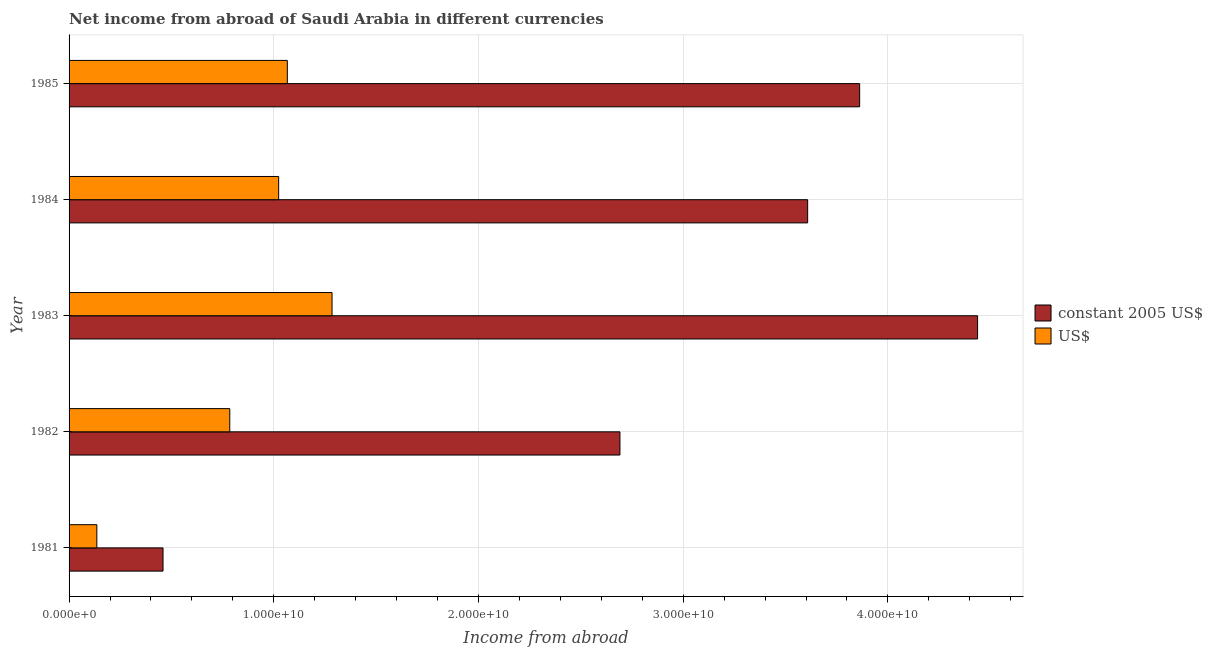How many different coloured bars are there?
Keep it short and to the point. 2. How many groups of bars are there?
Keep it short and to the point. 5. Are the number of bars on each tick of the Y-axis equal?
Your response must be concise. Yes. How many bars are there on the 1st tick from the top?
Offer a terse response. 2. What is the income from abroad in constant 2005 us$ in 1982?
Keep it short and to the point. 2.69e+1. Across all years, what is the maximum income from abroad in constant 2005 us$?
Ensure brevity in your answer.  4.44e+1. Across all years, what is the minimum income from abroad in constant 2005 us$?
Make the answer very short. 4.59e+09. In which year was the income from abroad in us$ minimum?
Provide a succinct answer. 1981. What is the total income from abroad in constant 2005 us$ in the graph?
Keep it short and to the point. 1.51e+11. What is the difference between the income from abroad in constant 2005 us$ in 1982 and that in 1985?
Keep it short and to the point. -1.17e+1. What is the difference between the income from abroad in us$ in 1984 and the income from abroad in constant 2005 us$ in 1985?
Your answer should be compact. -2.84e+1. What is the average income from abroad in constant 2005 us$ per year?
Keep it short and to the point. 3.01e+1. In the year 1984, what is the difference between the income from abroad in us$ and income from abroad in constant 2005 us$?
Provide a succinct answer. -2.58e+1. In how many years, is the income from abroad in us$ greater than 2000000000 units?
Your answer should be very brief. 4. What is the ratio of the income from abroad in us$ in 1981 to that in 1984?
Ensure brevity in your answer.  0.13. Is the income from abroad in constant 2005 us$ in 1981 less than that in 1984?
Make the answer very short. Yes. Is the difference between the income from abroad in constant 2005 us$ in 1982 and 1983 greater than the difference between the income from abroad in us$ in 1982 and 1983?
Provide a succinct answer. No. What is the difference between the highest and the second highest income from abroad in constant 2005 us$?
Your answer should be very brief. 5.76e+09. What is the difference between the highest and the lowest income from abroad in constant 2005 us$?
Your answer should be compact. 3.98e+1. What does the 2nd bar from the top in 1985 represents?
Ensure brevity in your answer.  Constant 2005 us$. What does the 1st bar from the bottom in 1981 represents?
Provide a succinct answer. Constant 2005 us$. Are all the bars in the graph horizontal?
Your answer should be compact. Yes. How many years are there in the graph?
Keep it short and to the point. 5. What is the difference between two consecutive major ticks on the X-axis?
Provide a succinct answer. 1.00e+1. Does the graph contain grids?
Your response must be concise. Yes. Where does the legend appear in the graph?
Your answer should be compact. Center right. What is the title of the graph?
Offer a terse response. Net income from abroad of Saudi Arabia in different currencies. Does "Fertility rate" appear as one of the legend labels in the graph?
Give a very brief answer. No. What is the label or title of the X-axis?
Your answer should be compact. Income from abroad. What is the label or title of the Y-axis?
Your answer should be compact. Year. What is the Income from abroad in constant 2005 US$ in 1981?
Offer a very short reply. 4.59e+09. What is the Income from abroad in US$ in 1981?
Your answer should be compact. 1.36e+09. What is the Income from abroad in constant 2005 US$ in 1982?
Make the answer very short. 2.69e+1. What is the Income from abroad in US$ in 1982?
Keep it short and to the point. 7.85e+09. What is the Income from abroad in constant 2005 US$ in 1983?
Offer a very short reply. 4.44e+1. What is the Income from abroad of US$ in 1983?
Offer a very short reply. 1.28e+1. What is the Income from abroad in constant 2005 US$ in 1984?
Ensure brevity in your answer.  3.61e+1. What is the Income from abroad in US$ in 1984?
Keep it short and to the point. 1.02e+1. What is the Income from abroad in constant 2005 US$ in 1985?
Give a very brief answer. 3.86e+1. What is the Income from abroad in US$ in 1985?
Provide a short and direct response. 1.07e+1. Across all years, what is the maximum Income from abroad of constant 2005 US$?
Offer a terse response. 4.44e+1. Across all years, what is the maximum Income from abroad in US$?
Your answer should be compact. 1.28e+1. Across all years, what is the minimum Income from abroad of constant 2005 US$?
Provide a short and direct response. 4.59e+09. Across all years, what is the minimum Income from abroad of US$?
Your response must be concise. 1.36e+09. What is the total Income from abroad of constant 2005 US$ in the graph?
Offer a very short reply. 1.51e+11. What is the total Income from abroad in US$ in the graph?
Your response must be concise. 4.30e+1. What is the difference between the Income from abroad in constant 2005 US$ in 1981 and that in 1982?
Provide a short and direct response. -2.23e+1. What is the difference between the Income from abroad in US$ in 1981 and that in 1982?
Make the answer very short. -6.49e+09. What is the difference between the Income from abroad in constant 2005 US$ in 1981 and that in 1983?
Ensure brevity in your answer.  -3.98e+1. What is the difference between the Income from abroad in US$ in 1981 and that in 1983?
Your answer should be very brief. -1.15e+1. What is the difference between the Income from abroad of constant 2005 US$ in 1981 and that in 1984?
Offer a terse response. -3.15e+1. What is the difference between the Income from abroad in US$ in 1981 and that in 1984?
Your response must be concise. -8.88e+09. What is the difference between the Income from abroad in constant 2005 US$ in 1981 and that in 1985?
Your answer should be compact. -3.40e+1. What is the difference between the Income from abroad in US$ in 1981 and that in 1985?
Offer a terse response. -9.31e+09. What is the difference between the Income from abroad in constant 2005 US$ in 1982 and that in 1983?
Make the answer very short. -1.75e+1. What is the difference between the Income from abroad of US$ in 1982 and that in 1983?
Your answer should be very brief. -5.00e+09. What is the difference between the Income from abroad of constant 2005 US$ in 1982 and that in 1984?
Your response must be concise. -9.17e+09. What is the difference between the Income from abroad in US$ in 1982 and that in 1984?
Provide a succinct answer. -2.39e+09. What is the difference between the Income from abroad in constant 2005 US$ in 1982 and that in 1985?
Offer a terse response. -1.17e+1. What is the difference between the Income from abroad in US$ in 1982 and that in 1985?
Your answer should be compact. -2.81e+09. What is the difference between the Income from abroad in constant 2005 US$ in 1983 and that in 1984?
Provide a short and direct response. 8.30e+09. What is the difference between the Income from abroad of US$ in 1983 and that in 1984?
Provide a short and direct response. 2.61e+09. What is the difference between the Income from abroad of constant 2005 US$ in 1983 and that in 1985?
Your response must be concise. 5.76e+09. What is the difference between the Income from abroad in US$ in 1983 and that in 1985?
Offer a terse response. 2.18e+09. What is the difference between the Income from abroad in constant 2005 US$ in 1984 and that in 1985?
Your answer should be compact. -2.54e+09. What is the difference between the Income from abroad in US$ in 1984 and that in 1985?
Ensure brevity in your answer.  -4.24e+08. What is the difference between the Income from abroad in constant 2005 US$ in 1981 and the Income from abroad in US$ in 1982?
Keep it short and to the point. -3.26e+09. What is the difference between the Income from abroad in constant 2005 US$ in 1981 and the Income from abroad in US$ in 1983?
Your answer should be very brief. -8.26e+09. What is the difference between the Income from abroad of constant 2005 US$ in 1981 and the Income from abroad of US$ in 1984?
Keep it short and to the point. -5.65e+09. What is the difference between the Income from abroad in constant 2005 US$ in 1981 and the Income from abroad in US$ in 1985?
Offer a terse response. -6.07e+09. What is the difference between the Income from abroad of constant 2005 US$ in 1982 and the Income from abroad of US$ in 1983?
Keep it short and to the point. 1.41e+1. What is the difference between the Income from abroad in constant 2005 US$ in 1982 and the Income from abroad in US$ in 1984?
Your response must be concise. 1.67e+1. What is the difference between the Income from abroad of constant 2005 US$ in 1982 and the Income from abroad of US$ in 1985?
Provide a short and direct response. 1.62e+1. What is the difference between the Income from abroad of constant 2005 US$ in 1983 and the Income from abroad of US$ in 1984?
Your answer should be compact. 3.41e+1. What is the difference between the Income from abroad in constant 2005 US$ in 1983 and the Income from abroad in US$ in 1985?
Make the answer very short. 3.37e+1. What is the difference between the Income from abroad of constant 2005 US$ in 1984 and the Income from abroad of US$ in 1985?
Offer a very short reply. 2.54e+1. What is the average Income from abroad of constant 2005 US$ per year?
Offer a very short reply. 3.01e+1. What is the average Income from abroad of US$ per year?
Make the answer very short. 8.59e+09. In the year 1981, what is the difference between the Income from abroad in constant 2005 US$ and Income from abroad in US$?
Keep it short and to the point. 3.23e+09. In the year 1982, what is the difference between the Income from abroad of constant 2005 US$ and Income from abroad of US$?
Make the answer very short. 1.91e+1. In the year 1983, what is the difference between the Income from abroad in constant 2005 US$ and Income from abroad in US$?
Your answer should be very brief. 3.15e+1. In the year 1984, what is the difference between the Income from abroad of constant 2005 US$ and Income from abroad of US$?
Give a very brief answer. 2.58e+1. In the year 1985, what is the difference between the Income from abroad in constant 2005 US$ and Income from abroad in US$?
Your answer should be very brief. 2.80e+1. What is the ratio of the Income from abroad of constant 2005 US$ in 1981 to that in 1982?
Offer a terse response. 0.17. What is the ratio of the Income from abroad in US$ in 1981 to that in 1982?
Your answer should be very brief. 0.17. What is the ratio of the Income from abroad in constant 2005 US$ in 1981 to that in 1983?
Provide a succinct answer. 0.1. What is the ratio of the Income from abroad in US$ in 1981 to that in 1983?
Ensure brevity in your answer.  0.11. What is the ratio of the Income from abroad in constant 2005 US$ in 1981 to that in 1984?
Ensure brevity in your answer.  0.13. What is the ratio of the Income from abroad of US$ in 1981 to that in 1984?
Ensure brevity in your answer.  0.13. What is the ratio of the Income from abroad in constant 2005 US$ in 1981 to that in 1985?
Provide a short and direct response. 0.12. What is the ratio of the Income from abroad of US$ in 1981 to that in 1985?
Make the answer very short. 0.13. What is the ratio of the Income from abroad of constant 2005 US$ in 1982 to that in 1983?
Your answer should be very brief. 0.61. What is the ratio of the Income from abroad of US$ in 1982 to that in 1983?
Keep it short and to the point. 0.61. What is the ratio of the Income from abroad in constant 2005 US$ in 1982 to that in 1984?
Offer a very short reply. 0.75. What is the ratio of the Income from abroad of US$ in 1982 to that in 1984?
Your response must be concise. 0.77. What is the ratio of the Income from abroad in constant 2005 US$ in 1982 to that in 1985?
Offer a very short reply. 0.7. What is the ratio of the Income from abroad in US$ in 1982 to that in 1985?
Provide a succinct answer. 0.74. What is the ratio of the Income from abroad in constant 2005 US$ in 1983 to that in 1984?
Ensure brevity in your answer.  1.23. What is the ratio of the Income from abroad in US$ in 1983 to that in 1984?
Provide a succinct answer. 1.25. What is the ratio of the Income from abroad of constant 2005 US$ in 1983 to that in 1985?
Provide a succinct answer. 1.15. What is the ratio of the Income from abroad in US$ in 1983 to that in 1985?
Give a very brief answer. 1.2. What is the ratio of the Income from abroad of constant 2005 US$ in 1984 to that in 1985?
Offer a very short reply. 0.93. What is the ratio of the Income from abroad of US$ in 1984 to that in 1985?
Make the answer very short. 0.96. What is the difference between the highest and the second highest Income from abroad of constant 2005 US$?
Make the answer very short. 5.76e+09. What is the difference between the highest and the second highest Income from abroad of US$?
Provide a short and direct response. 2.18e+09. What is the difference between the highest and the lowest Income from abroad in constant 2005 US$?
Give a very brief answer. 3.98e+1. What is the difference between the highest and the lowest Income from abroad in US$?
Provide a short and direct response. 1.15e+1. 